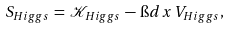Convert formula to latex. <formula><loc_0><loc_0><loc_500><loc_500>S _ { H i g g s } \, = \, \mathcal { K } _ { H i g g s } \, - \, \i d x \, V _ { H i g g s } ,</formula> 